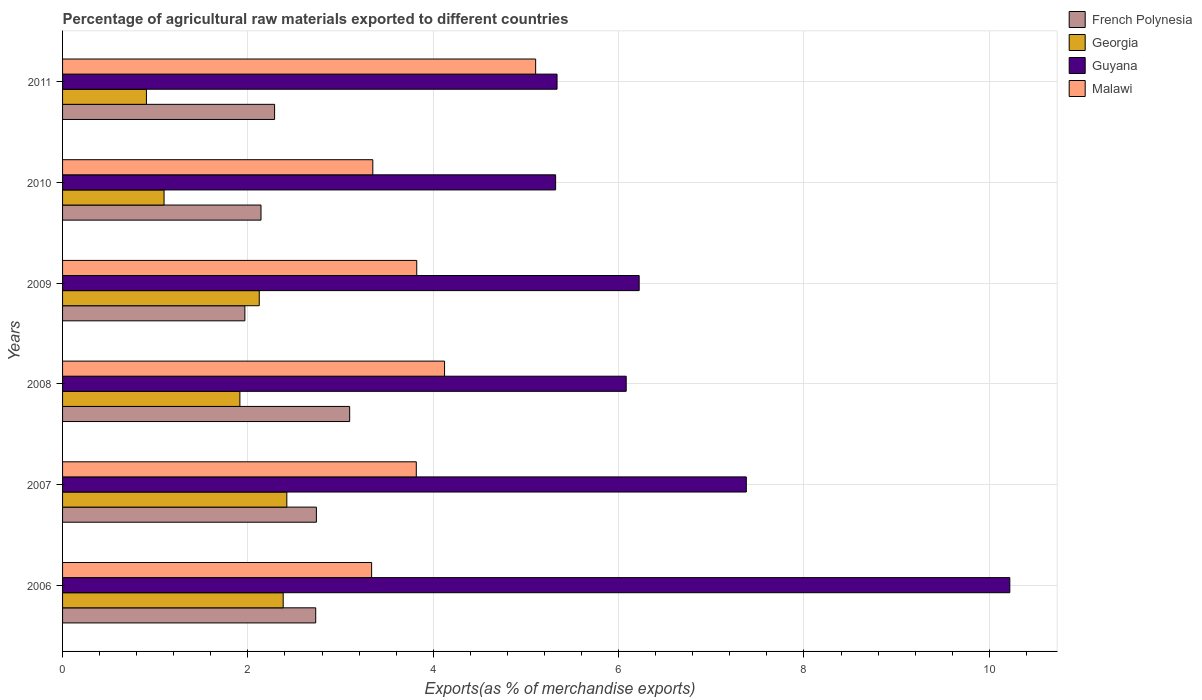How many different coloured bars are there?
Provide a short and direct response. 4. How many groups of bars are there?
Your response must be concise. 6. How many bars are there on the 4th tick from the top?
Offer a very short reply. 4. How many bars are there on the 3rd tick from the bottom?
Provide a succinct answer. 4. What is the label of the 1st group of bars from the top?
Your answer should be compact. 2011. What is the percentage of exports to different countries in Malawi in 2009?
Offer a very short reply. 3.82. Across all years, what is the maximum percentage of exports to different countries in French Polynesia?
Make the answer very short. 3.1. Across all years, what is the minimum percentage of exports to different countries in Georgia?
Your response must be concise. 0.91. In which year was the percentage of exports to different countries in Georgia minimum?
Your answer should be very brief. 2011. What is the total percentage of exports to different countries in Malawi in the graph?
Provide a short and direct response. 23.55. What is the difference between the percentage of exports to different countries in Guyana in 2006 and that in 2009?
Offer a terse response. 4. What is the difference between the percentage of exports to different countries in Georgia in 2006 and the percentage of exports to different countries in Guyana in 2008?
Your response must be concise. -3.7. What is the average percentage of exports to different countries in French Polynesia per year?
Your answer should be very brief. 2.49. In the year 2006, what is the difference between the percentage of exports to different countries in Georgia and percentage of exports to different countries in Malawi?
Provide a short and direct response. -0.95. What is the ratio of the percentage of exports to different countries in Georgia in 2008 to that in 2010?
Provide a succinct answer. 1.75. Is the percentage of exports to different countries in French Polynesia in 2010 less than that in 2011?
Your answer should be compact. Yes. Is the difference between the percentage of exports to different countries in Georgia in 2010 and 2011 greater than the difference between the percentage of exports to different countries in Malawi in 2010 and 2011?
Keep it short and to the point. Yes. What is the difference between the highest and the second highest percentage of exports to different countries in Georgia?
Provide a succinct answer. 0.04. What is the difference between the highest and the lowest percentage of exports to different countries in Georgia?
Keep it short and to the point. 1.51. In how many years, is the percentage of exports to different countries in Malawi greater than the average percentage of exports to different countries in Malawi taken over all years?
Make the answer very short. 2. What does the 3rd bar from the top in 2010 represents?
Your response must be concise. Georgia. What does the 2nd bar from the bottom in 2007 represents?
Give a very brief answer. Georgia. Is it the case that in every year, the sum of the percentage of exports to different countries in Georgia and percentage of exports to different countries in Malawi is greater than the percentage of exports to different countries in Guyana?
Your response must be concise. No. What is the difference between two consecutive major ticks on the X-axis?
Keep it short and to the point. 2. Does the graph contain grids?
Keep it short and to the point. Yes. How are the legend labels stacked?
Offer a very short reply. Vertical. What is the title of the graph?
Your answer should be very brief. Percentage of agricultural raw materials exported to different countries. What is the label or title of the X-axis?
Offer a terse response. Exports(as % of merchandise exports). What is the Exports(as % of merchandise exports) in French Polynesia in 2006?
Ensure brevity in your answer.  2.73. What is the Exports(as % of merchandise exports) in Georgia in 2006?
Offer a terse response. 2.38. What is the Exports(as % of merchandise exports) of Guyana in 2006?
Ensure brevity in your answer.  10.22. What is the Exports(as % of merchandise exports) of Malawi in 2006?
Provide a succinct answer. 3.33. What is the Exports(as % of merchandise exports) of French Polynesia in 2007?
Offer a terse response. 2.74. What is the Exports(as % of merchandise exports) in Georgia in 2007?
Give a very brief answer. 2.42. What is the Exports(as % of merchandise exports) of Guyana in 2007?
Your response must be concise. 7.38. What is the Exports(as % of merchandise exports) of Malawi in 2007?
Make the answer very short. 3.82. What is the Exports(as % of merchandise exports) of French Polynesia in 2008?
Your answer should be compact. 3.1. What is the Exports(as % of merchandise exports) of Georgia in 2008?
Provide a short and direct response. 1.91. What is the Exports(as % of merchandise exports) in Guyana in 2008?
Provide a short and direct response. 6.08. What is the Exports(as % of merchandise exports) of Malawi in 2008?
Provide a short and direct response. 4.12. What is the Exports(as % of merchandise exports) of French Polynesia in 2009?
Keep it short and to the point. 1.97. What is the Exports(as % of merchandise exports) in Georgia in 2009?
Provide a succinct answer. 2.12. What is the Exports(as % of merchandise exports) of Guyana in 2009?
Give a very brief answer. 6.22. What is the Exports(as % of merchandise exports) of Malawi in 2009?
Your response must be concise. 3.82. What is the Exports(as % of merchandise exports) in French Polynesia in 2010?
Make the answer very short. 2.14. What is the Exports(as % of merchandise exports) in Georgia in 2010?
Make the answer very short. 1.1. What is the Exports(as % of merchandise exports) of Guyana in 2010?
Your answer should be compact. 5.32. What is the Exports(as % of merchandise exports) of Malawi in 2010?
Your answer should be compact. 3.35. What is the Exports(as % of merchandise exports) of French Polynesia in 2011?
Provide a succinct answer. 2.29. What is the Exports(as % of merchandise exports) of Georgia in 2011?
Provide a short and direct response. 0.91. What is the Exports(as % of merchandise exports) in Guyana in 2011?
Keep it short and to the point. 5.34. What is the Exports(as % of merchandise exports) in Malawi in 2011?
Your answer should be very brief. 5.1. Across all years, what is the maximum Exports(as % of merchandise exports) of French Polynesia?
Your answer should be compact. 3.1. Across all years, what is the maximum Exports(as % of merchandise exports) in Georgia?
Keep it short and to the point. 2.42. Across all years, what is the maximum Exports(as % of merchandise exports) of Guyana?
Provide a succinct answer. 10.22. Across all years, what is the maximum Exports(as % of merchandise exports) in Malawi?
Offer a terse response. 5.1. Across all years, what is the minimum Exports(as % of merchandise exports) in French Polynesia?
Give a very brief answer. 1.97. Across all years, what is the minimum Exports(as % of merchandise exports) in Georgia?
Keep it short and to the point. 0.91. Across all years, what is the minimum Exports(as % of merchandise exports) of Guyana?
Your answer should be very brief. 5.32. Across all years, what is the minimum Exports(as % of merchandise exports) of Malawi?
Keep it short and to the point. 3.33. What is the total Exports(as % of merchandise exports) in French Polynesia in the graph?
Provide a succinct answer. 14.96. What is the total Exports(as % of merchandise exports) in Georgia in the graph?
Your answer should be very brief. 10.84. What is the total Exports(as % of merchandise exports) in Guyana in the graph?
Provide a succinct answer. 40.56. What is the total Exports(as % of merchandise exports) in Malawi in the graph?
Ensure brevity in your answer.  23.55. What is the difference between the Exports(as % of merchandise exports) of French Polynesia in 2006 and that in 2007?
Give a very brief answer. -0.01. What is the difference between the Exports(as % of merchandise exports) of Georgia in 2006 and that in 2007?
Offer a very short reply. -0.04. What is the difference between the Exports(as % of merchandise exports) of Guyana in 2006 and that in 2007?
Offer a very short reply. 2.84. What is the difference between the Exports(as % of merchandise exports) in Malawi in 2006 and that in 2007?
Provide a succinct answer. -0.48. What is the difference between the Exports(as % of merchandise exports) in French Polynesia in 2006 and that in 2008?
Keep it short and to the point. -0.37. What is the difference between the Exports(as % of merchandise exports) in Georgia in 2006 and that in 2008?
Make the answer very short. 0.47. What is the difference between the Exports(as % of merchandise exports) in Guyana in 2006 and that in 2008?
Provide a short and direct response. 4.14. What is the difference between the Exports(as % of merchandise exports) in Malawi in 2006 and that in 2008?
Ensure brevity in your answer.  -0.79. What is the difference between the Exports(as % of merchandise exports) of French Polynesia in 2006 and that in 2009?
Offer a terse response. 0.76. What is the difference between the Exports(as % of merchandise exports) in Georgia in 2006 and that in 2009?
Your answer should be compact. 0.26. What is the difference between the Exports(as % of merchandise exports) in Guyana in 2006 and that in 2009?
Ensure brevity in your answer.  4. What is the difference between the Exports(as % of merchandise exports) in Malawi in 2006 and that in 2009?
Provide a succinct answer. -0.49. What is the difference between the Exports(as % of merchandise exports) in French Polynesia in 2006 and that in 2010?
Offer a terse response. 0.59. What is the difference between the Exports(as % of merchandise exports) in Georgia in 2006 and that in 2010?
Provide a short and direct response. 1.29. What is the difference between the Exports(as % of merchandise exports) in Guyana in 2006 and that in 2010?
Your answer should be compact. 4.9. What is the difference between the Exports(as % of merchandise exports) of Malawi in 2006 and that in 2010?
Your answer should be compact. -0.01. What is the difference between the Exports(as % of merchandise exports) in French Polynesia in 2006 and that in 2011?
Provide a short and direct response. 0.44. What is the difference between the Exports(as % of merchandise exports) of Georgia in 2006 and that in 2011?
Ensure brevity in your answer.  1.48. What is the difference between the Exports(as % of merchandise exports) of Guyana in 2006 and that in 2011?
Ensure brevity in your answer.  4.89. What is the difference between the Exports(as % of merchandise exports) of Malawi in 2006 and that in 2011?
Your response must be concise. -1.77. What is the difference between the Exports(as % of merchandise exports) of French Polynesia in 2007 and that in 2008?
Offer a terse response. -0.36. What is the difference between the Exports(as % of merchandise exports) of Georgia in 2007 and that in 2008?
Make the answer very short. 0.51. What is the difference between the Exports(as % of merchandise exports) of Guyana in 2007 and that in 2008?
Ensure brevity in your answer.  1.3. What is the difference between the Exports(as % of merchandise exports) in Malawi in 2007 and that in 2008?
Your answer should be compact. -0.3. What is the difference between the Exports(as % of merchandise exports) in French Polynesia in 2007 and that in 2009?
Your response must be concise. 0.77. What is the difference between the Exports(as % of merchandise exports) of Georgia in 2007 and that in 2009?
Ensure brevity in your answer.  0.3. What is the difference between the Exports(as % of merchandise exports) in Guyana in 2007 and that in 2009?
Offer a terse response. 1.16. What is the difference between the Exports(as % of merchandise exports) in Malawi in 2007 and that in 2009?
Ensure brevity in your answer.  -0. What is the difference between the Exports(as % of merchandise exports) of French Polynesia in 2007 and that in 2010?
Provide a succinct answer. 0.6. What is the difference between the Exports(as % of merchandise exports) of Georgia in 2007 and that in 2010?
Offer a terse response. 1.32. What is the difference between the Exports(as % of merchandise exports) in Guyana in 2007 and that in 2010?
Offer a very short reply. 2.06. What is the difference between the Exports(as % of merchandise exports) in Malawi in 2007 and that in 2010?
Your answer should be compact. 0.47. What is the difference between the Exports(as % of merchandise exports) of French Polynesia in 2007 and that in 2011?
Keep it short and to the point. 0.45. What is the difference between the Exports(as % of merchandise exports) of Georgia in 2007 and that in 2011?
Ensure brevity in your answer.  1.51. What is the difference between the Exports(as % of merchandise exports) in Guyana in 2007 and that in 2011?
Your answer should be very brief. 2.04. What is the difference between the Exports(as % of merchandise exports) of Malawi in 2007 and that in 2011?
Make the answer very short. -1.29. What is the difference between the Exports(as % of merchandise exports) in French Polynesia in 2008 and that in 2009?
Your answer should be very brief. 1.13. What is the difference between the Exports(as % of merchandise exports) of Georgia in 2008 and that in 2009?
Give a very brief answer. -0.21. What is the difference between the Exports(as % of merchandise exports) of Guyana in 2008 and that in 2009?
Ensure brevity in your answer.  -0.14. What is the difference between the Exports(as % of merchandise exports) of Malawi in 2008 and that in 2009?
Provide a short and direct response. 0.3. What is the difference between the Exports(as % of merchandise exports) of French Polynesia in 2008 and that in 2010?
Make the answer very short. 0.96. What is the difference between the Exports(as % of merchandise exports) of Georgia in 2008 and that in 2010?
Keep it short and to the point. 0.82. What is the difference between the Exports(as % of merchandise exports) of Guyana in 2008 and that in 2010?
Provide a short and direct response. 0.76. What is the difference between the Exports(as % of merchandise exports) in Malawi in 2008 and that in 2010?
Keep it short and to the point. 0.77. What is the difference between the Exports(as % of merchandise exports) in French Polynesia in 2008 and that in 2011?
Offer a very short reply. 0.81. What is the difference between the Exports(as % of merchandise exports) of Georgia in 2008 and that in 2011?
Give a very brief answer. 1.01. What is the difference between the Exports(as % of merchandise exports) in Guyana in 2008 and that in 2011?
Ensure brevity in your answer.  0.75. What is the difference between the Exports(as % of merchandise exports) of Malawi in 2008 and that in 2011?
Offer a terse response. -0.98. What is the difference between the Exports(as % of merchandise exports) in French Polynesia in 2009 and that in 2010?
Keep it short and to the point. -0.17. What is the difference between the Exports(as % of merchandise exports) in Georgia in 2009 and that in 2010?
Offer a very short reply. 1.03. What is the difference between the Exports(as % of merchandise exports) in Guyana in 2009 and that in 2010?
Your response must be concise. 0.9. What is the difference between the Exports(as % of merchandise exports) in Malawi in 2009 and that in 2010?
Provide a succinct answer. 0.47. What is the difference between the Exports(as % of merchandise exports) of French Polynesia in 2009 and that in 2011?
Your response must be concise. -0.32. What is the difference between the Exports(as % of merchandise exports) of Georgia in 2009 and that in 2011?
Make the answer very short. 1.22. What is the difference between the Exports(as % of merchandise exports) of Guyana in 2009 and that in 2011?
Offer a terse response. 0.89. What is the difference between the Exports(as % of merchandise exports) in Malawi in 2009 and that in 2011?
Your answer should be very brief. -1.28. What is the difference between the Exports(as % of merchandise exports) of French Polynesia in 2010 and that in 2011?
Offer a very short reply. -0.15. What is the difference between the Exports(as % of merchandise exports) in Georgia in 2010 and that in 2011?
Offer a terse response. 0.19. What is the difference between the Exports(as % of merchandise exports) in Guyana in 2010 and that in 2011?
Ensure brevity in your answer.  -0.02. What is the difference between the Exports(as % of merchandise exports) of Malawi in 2010 and that in 2011?
Your answer should be compact. -1.76. What is the difference between the Exports(as % of merchandise exports) of French Polynesia in 2006 and the Exports(as % of merchandise exports) of Georgia in 2007?
Your response must be concise. 0.31. What is the difference between the Exports(as % of merchandise exports) of French Polynesia in 2006 and the Exports(as % of merchandise exports) of Guyana in 2007?
Give a very brief answer. -4.65. What is the difference between the Exports(as % of merchandise exports) of French Polynesia in 2006 and the Exports(as % of merchandise exports) of Malawi in 2007?
Provide a short and direct response. -1.09. What is the difference between the Exports(as % of merchandise exports) in Georgia in 2006 and the Exports(as % of merchandise exports) in Guyana in 2007?
Offer a terse response. -5. What is the difference between the Exports(as % of merchandise exports) in Georgia in 2006 and the Exports(as % of merchandise exports) in Malawi in 2007?
Your answer should be compact. -1.44. What is the difference between the Exports(as % of merchandise exports) of Guyana in 2006 and the Exports(as % of merchandise exports) of Malawi in 2007?
Your response must be concise. 6.4. What is the difference between the Exports(as % of merchandise exports) of French Polynesia in 2006 and the Exports(as % of merchandise exports) of Georgia in 2008?
Provide a short and direct response. 0.82. What is the difference between the Exports(as % of merchandise exports) of French Polynesia in 2006 and the Exports(as % of merchandise exports) of Guyana in 2008?
Keep it short and to the point. -3.35. What is the difference between the Exports(as % of merchandise exports) of French Polynesia in 2006 and the Exports(as % of merchandise exports) of Malawi in 2008?
Keep it short and to the point. -1.39. What is the difference between the Exports(as % of merchandise exports) in Georgia in 2006 and the Exports(as % of merchandise exports) in Guyana in 2008?
Offer a very short reply. -3.7. What is the difference between the Exports(as % of merchandise exports) in Georgia in 2006 and the Exports(as % of merchandise exports) in Malawi in 2008?
Provide a short and direct response. -1.74. What is the difference between the Exports(as % of merchandise exports) in Guyana in 2006 and the Exports(as % of merchandise exports) in Malawi in 2008?
Your answer should be very brief. 6.1. What is the difference between the Exports(as % of merchandise exports) in French Polynesia in 2006 and the Exports(as % of merchandise exports) in Georgia in 2009?
Your answer should be compact. 0.61. What is the difference between the Exports(as % of merchandise exports) of French Polynesia in 2006 and the Exports(as % of merchandise exports) of Guyana in 2009?
Your response must be concise. -3.49. What is the difference between the Exports(as % of merchandise exports) of French Polynesia in 2006 and the Exports(as % of merchandise exports) of Malawi in 2009?
Your answer should be compact. -1.09. What is the difference between the Exports(as % of merchandise exports) of Georgia in 2006 and the Exports(as % of merchandise exports) of Guyana in 2009?
Offer a terse response. -3.84. What is the difference between the Exports(as % of merchandise exports) in Georgia in 2006 and the Exports(as % of merchandise exports) in Malawi in 2009?
Make the answer very short. -1.44. What is the difference between the Exports(as % of merchandise exports) of Guyana in 2006 and the Exports(as % of merchandise exports) of Malawi in 2009?
Give a very brief answer. 6.4. What is the difference between the Exports(as % of merchandise exports) in French Polynesia in 2006 and the Exports(as % of merchandise exports) in Georgia in 2010?
Keep it short and to the point. 1.64. What is the difference between the Exports(as % of merchandise exports) in French Polynesia in 2006 and the Exports(as % of merchandise exports) in Guyana in 2010?
Provide a short and direct response. -2.59. What is the difference between the Exports(as % of merchandise exports) in French Polynesia in 2006 and the Exports(as % of merchandise exports) in Malawi in 2010?
Your response must be concise. -0.62. What is the difference between the Exports(as % of merchandise exports) of Georgia in 2006 and the Exports(as % of merchandise exports) of Guyana in 2010?
Provide a succinct answer. -2.94. What is the difference between the Exports(as % of merchandise exports) in Georgia in 2006 and the Exports(as % of merchandise exports) in Malawi in 2010?
Your answer should be compact. -0.97. What is the difference between the Exports(as % of merchandise exports) in Guyana in 2006 and the Exports(as % of merchandise exports) in Malawi in 2010?
Offer a terse response. 6.87. What is the difference between the Exports(as % of merchandise exports) in French Polynesia in 2006 and the Exports(as % of merchandise exports) in Georgia in 2011?
Your answer should be compact. 1.83. What is the difference between the Exports(as % of merchandise exports) of French Polynesia in 2006 and the Exports(as % of merchandise exports) of Guyana in 2011?
Your answer should be very brief. -2.6. What is the difference between the Exports(as % of merchandise exports) of French Polynesia in 2006 and the Exports(as % of merchandise exports) of Malawi in 2011?
Make the answer very short. -2.37. What is the difference between the Exports(as % of merchandise exports) of Georgia in 2006 and the Exports(as % of merchandise exports) of Guyana in 2011?
Give a very brief answer. -2.96. What is the difference between the Exports(as % of merchandise exports) of Georgia in 2006 and the Exports(as % of merchandise exports) of Malawi in 2011?
Give a very brief answer. -2.72. What is the difference between the Exports(as % of merchandise exports) of Guyana in 2006 and the Exports(as % of merchandise exports) of Malawi in 2011?
Your response must be concise. 5.12. What is the difference between the Exports(as % of merchandise exports) of French Polynesia in 2007 and the Exports(as % of merchandise exports) of Georgia in 2008?
Your answer should be very brief. 0.83. What is the difference between the Exports(as % of merchandise exports) in French Polynesia in 2007 and the Exports(as % of merchandise exports) in Guyana in 2008?
Your response must be concise. -3.34. What is the difference between the Exports(as % of merchandise exports) in French Polynesia in 2007 and the Exports(as % of merchandise exports) in Malawi in 2008?
Offer a terse response. -1.38. What is the difference between the Exports(as % of merchandise exports) in Georgia in 2007 and the Exports(as % of merchandise exports) in Guyana in 2008?
Provide a succinct answer. -3.66. What is the difference between the Exports(as % of merchandise exports) of Georgia in 2007 and the Exports(as % of merchandise exports) of Malawi in 2008?
Your answer should be very brief. -1.7. What is the difference between the Exports(as % of merchandise exports) of Guyana in 2007 and the Exports(as % of merchandise exports) of Malawi in 2008?
Offer a terse response. 3.26. What is the difference between the Exports(as % of merchandise exports) of French Polynesia in 2007 and the Exports(as % of merchandise exports) of Georgia in 2009?
Make the answer very short. 0.62. What is the difference between the Exports(as % of merchandise exports) of French Polynesia in 2007 and the Exports(as % of merchandise exports) of Guyana in 2009?
Keep it short and to the point. -3.48. What is the difference between the Exports(as % of merchandise exports) in French Polynesia in 2007 and the Exports(as % of merchandise exports) in Malawi in 2009?
Make the answer very short. -1.08. What is the difference between the Exports(as % of merchandise exports) in Georgia in 2007 and the Exports(as % of merchandise exports) in Guyana in 2009?
Make the answer very short. -3.8. What is the difference between the Exports(as % of merchandise exports) of Georgia in 2007 and the Exports(as % of merchandise exports) of Malawi in 2009?
Make the answer very short. -1.4. What is the difference between the Exports(as % of merchandise exports) in Guyana in 2007 and the Exports(as % of merchandise exports) in Malawi in 2009?
Provide a succinct answer. 3.56. What is the difference between the Exports(as % of merchandise exports) of French Polynesia in 2007 and the Exports(as % of merchandise exports) of Georgia in 2010?
Make the answer very short. 1.64. What is the difference between the Exports(as % of merchandise exports) in French Polynesia in 2007 and the Exports(as % of merchandise exports) in Guyana in 2010?
Your answer should be very brief. -2.58. What is the difference between the Exports(as % of merchandise exports) in French Polynesia in 2007 and the Exports(as % of merchandise exports) in Malawi in 2010?
Make the answer very short. -0.61. What is the difference between the Exports(as % of merchandise exports) of Georgia in 2007 and the Exports(as % of merchandise exports) of Guyana in 2010?
Provide a succinct answer. -2.9. What is the difference between the Exports(as % of merchandise exports) of Georgia in 2007 and the Exports(as % of merchandise exports) of Malawi in 2010?
Your response must be concise. -0.93. What is the difference between the Exports(as % of merchandise exports) of Guyana in 2007 and the Exports(as % of merchandise exports) of Malawi in 2010?
Your response must be concise. 4.03. What is the difference between the Exports(as % of merchandise exports) of French Polynesia in 2007 and the Exports(as % of merchandise exports) of Georgia in 2011?
Offer a terse response. 1.83. What is the difference between the Exports(as % of merchandise exports) of French Polynesia in 2007 and the Exports(as % of merchandise exports) of Guyana in 2011?
Give a very brief answer. -2.6. What is the difference between the Exports(as % of merchandise exports) in French Polynesia in 2007 and the Exports(as % of merchandise exports) in Malawi in 2011?
Offer a terse response. -2.37. What is the difference between the Exports(as % of merchandise exports) of Georgia in 2007 and the Exports(as % of merchandise exports) of Guyana in 2011?
Your answer should be compact. -2.92. What is the difference between the Exports(as % of merchandise exports) in Georgia in 2007 and the Exports(as % of merchandise exports) in Malawi in 2011?
Provide a short and direct response. -2.69. What is the difference between the Exports(as % of merchandise exports) in Guyana in 2007 and the Exports(as % of merchandise exports) in Malawi in 2011?
Your answer should be compact. 2.27. What is the difference between the Exports(as % of merchandise exports) in French Polynesia in 2008 and the Exports(as % of merchandise exports) in Georgia in 2009?
Give a very brief answer. 0.98. What is the difference between the Exports(as % of merchandise exports) in French Polynesia in 2008 and the Exports(as % of merchandise exports) in Guyana in 2009?
Provide a short and direct response. -3.12. What is the difference between the Exports(as % of merchandise exports) in French Polynesia in 2008 and the Exports(as % of merchandise exports) in Malawi in 2009?
Provide a succinct answer. -0.72. What is the difference between the Exports(as % of merchandise exports) of Georgia in 2008 and the Exports(as % of merchandise exports) of Guyana in 2009?
Offer a very short reply. -4.31. What is the difference between the Exports(as % of merchandise exports) of Georgia in 2008 and the Exports(as % of merchandise exports) of Malawi in 2009?
Your answer should be very brief. -1.91. What is the difference between the Exports(as % of merchandise exports) in Guyana in 2008 and the Exports(as % of merchandise exports) in Malawi in 2009?
Keep it short and to the point. 2.26. What is the difference between the Exports(as % of merchandise exports) of French Polynesia in 2008 and the Exports(as % of merchandise exports) of Georgia in 2010?
Give a very brief answer. 2. What is the difference between the Exports(as % of merchandise exports) in French Polynesia in 2008 and the Exports(as % of merchandise exports) in Guyana in 2010?
Your answer should be very brief. -2.22. What is the difference between the Exports(as % of merchandise exports) in French Polynesia in 2008 and the Exports(as % of merchandise exports) in Malawi in 2010?
Offer a terse response. -0.25. What is the difference between the Exports(as % of merchandise exports) in Georgia in 2008 and the Exports(as % of merchandise exports) in Guyana in 2010?
Make the answer very short. -3.41. What is the difference between the Exports(as % of merchandise exports) in Georgia in 2008 and the Exports(as % of merchandise exports) in Malawi in 2010?
Provide a succinct answer. -1.43. What is the difference between the Exports(as % of merchandise exports) of Guyana in 2008 and the Exports(as % of merchandise exports) of Malawi in 2010?
Your answer should be very brief. 2.73. What is the difference between the Exports(as % of merchandise exports) of French Polynesia in 2008 and the Exports(as % of merchandise exports) of Georgia in 2011?
Ensure brevity in your answer.  2.19. What is the difference between the Exports(as % of merchandise exports) in French Polynesia in 2008 and the Exports(as % of merchandise exports) in Guyana in 2011?
Your answer should be very brief. -2.24. What is the difference between the Exports(as % of merchandise exports) of French Polynesia in 2008 and the Exports(as % of merchandise exports) of Malawi in 2011?
Keep it short and to the point. -2.01. What is the difference between the Exports(as % of merchandise exports) of Georgia in 2008 and the Exports(as % of merchandise exports) of Guyana in 2011?
Your answer should be very brief. -3.42. What is the difference between the Exports(as % of merchandise exports) of Georgia in 2008 and the Exports(as % of merchandise exports) of Malawi in 2011?
Your answer should be very brief. -3.19. What is the difference between the Exports(as % of merchandise exports) in Guyana in 2008 and the Exports(as % of merchandise exports) in Malawi in 2011?
Your answer should be compact. 0.98. What is the difference between the Exports(as % of merchandise exports) of French Polynesia in 2009 and the Exports(as % of merchandise exports) of Georgia in 2010?
Provide a short and direct response. 0.87. What is the difference between the Exports(as % of merchandise exports) in French Polynesia in 2009 and the Exports(as % of merchandise exports) in Guyana in 2010?
Your answer should be compact. -3.35. What is the difference between the Exports(as % of merchandise exports) in French Polynesia in 2009 and the Exports(as % of merchandise exports) in Malawi in 2010?
Keep it short and to the point. -1.38. What is the difference between the Exports(as % of merchandise exports) in Georgia in 2009 and the Exports(as % of merchandise exports) in Guyana in 2010?
Keep it short and to the point. -3.2. What is the difference between the Exports(as % of merchandise exports) in Georgia in 2009 and the Exports(as % of merchandise exports) in Malawi in 2010?
Your response must be concise. -1.23. What is the difference between the Exports(as % of merchandise exports) in Guyana in 2009 and the Exports(as % of merchandise exports) in Malawi in 2010?
Offer a terse response. 2.87. What is the difference between the Exports(as % of merchandise exports) of French Polynesia in 2009 and the Exports(as % of merchandise exports) of Georgia in 2011?
Ensure brevity in your answer.  1.06. What is the difference between the Exports(as % of merchandise exports) of French Polynesia in 2009 and the Exports(as % of merchandise exports) of Guyana in 2011?
Offer a very short reply. -3.37. What is the difference between the Exports(as % of merchandise exports) in French Polynesia in 2009 and the Exports(as % of merchandise exports) in Malawi in 2011?
Your answer should be compact. -3.14. What is the difference between the Exports(as % of merchandise exports) of Georgia in 2009 and the Exports(as % of merchandise exports) of Guyana in 2011?
Make the answer very short. -3.21. What is the difference between the Exports(as % of merchandise exports) in Georgia in 2009 and the Exports(as % of merchandise exports) in Malawi in 2011?
Provide a succinct answer. -2.98. What is the difference between the Exports(as % of merchandise exports) in Guyana in 2009 and the Exports(as % of merchandise exports) in Malawi in 2011?
Give a very brief answer. 1.12. What is the difference between the Exports(as % of merchandise exports) in French Polynesia in 2010 and the Exports(as % of merchandise exports) in Georgia in 2011?
Ensure brevity in your answer.  1.24. What is the difference between the Exports(as % of merchandise exports) of French Polynesia in 2010 and the Exports(as % of merchandise exports) of Guyana in 2011?
Make the answer very short. -3.19. What is the difference between the Exports(as % of merchandise exports) in French Polynesia in 2010 and the Exports(as % of merchandise exports) in Malawi in 2011?
Offer a terse response. -2.96. What is the difference between the Exports(as % of merchandise exports) of Georgia in 2010 and the Exports(as % of merchandise exports) of Guyana in 2011?
Keep it short and to the point. -4.24. What is the difference between the Exports(as % of merchandise exports) of Georgia in 2010 and the Exports(as % of merchandise exports) of Malawi in 2011?
Keep it short and to the point. -4.01. What is the difference between the Exports(as % of merchandise exports) of Guyana in 2010 and the Exports(as % of merchandise exports) of Malawi in 2011?
Your response must be concise. 0.22. What is the average Exports(as % of merchandise exports) of French Polynesia per year?
Make the answer very short. 2.49. What is the average Exports(as % of merchandise exports) in Georgia per year?
Offer a very short reply. 1.81. What is the average Exports(as % of merchandise exports) in Guyana per year?
Your response must be concise. 6.76. What is the average Exports(as % of merchandise exports) of Malawi per year?
Provide a short and direct response. 3.92. In the year 2006, what is the difference between the Exports(as % of merchandise exports) of French Polynesia and Exports(as % of merchandise exports) of Georgia?
Give a very brief answer. 0.35. In the year 2006, what is the difference between the Exports(as % of merchandise exports) in French Polynesia and Exports(as % of merchandise exports) in Guyana?
Give a very brief answer. -7.49. In the year 2006, what is the difference between the Exports(as % of merchandise exports) of French Polynesia and Exports(as % of merchandise exports) of Malawi?
Your answer should be compact. -0.6. In the year 2006, what is the difference between the Exports(as % of merchandise exports) of Georgia and Exports(as % of merchandise exports) of Guyana?
Make the answer very short. -7.84. In the year 2006, what is the difference between the Exports(as % of merchandise exports) in Georgia and Exports(as % of merchandise exports) in Malawi?
Provide a succinct answer. -0.95. In the year 2006, what is the difference between the Exports(as % of merchandise exports) of Guyana and Exports(as % of merchandise exports) of Malawi?
Ensure brevity in your answer.  6.89. In the year 2007, what is the difference between the Exports(as % of merchandise exports) of French Polynesia and Exports(as % of merchandise exports) of Georgia?
Offer a terse response. 0.32. In the year 2007, what is the difference between the Exports(as % of merchandise exports) in French Polynesia and Exports(as % of merchandise exports) in Guyana?
Provide a short and direct response. -4.64. In the year 2007, what is the difference between the Exports(as % of merchandise exports) of French Polynesia and Exports(as % of merchandise exports) of Malawi?
Your answer should be compact. -1.08. In the year 2007, what is the difference between the Exports(as % of merchandise exports) of Georgia and Exports(as % of merchandise exports) of Guyana?
Keep it short and to the point. -4.96. In the year 2007, what is the difference between the Exports(as % of merchandise exports) of Georgia and Exports(as % of merchandise exports) of Malawi?
Give a very brief answer. -1.4. In the year 2007, what is the difference between the Exports(as % of merchandise exports) in Guyana and Exports(as % of merchandise exports) in Malawi?
Make the answer very short. 3.56. In the year 2008, what is the difference between the Exports(as % of merchandise exports) of French Polynesia and Exports(as % of merchandise exports) of Georgia?
Offer a very short reply. 1.18. In the year 2008, what is the difference between the Exports(as % of merchandise exports) of French Polynesia and Exports(as % of merchandise exports) of Guyana?
Offer a terse response. -2.98. In the year 2008, what is the difference between the Exports(as % of merchandise exports) of French Polynesia and Exports(as % of merchandise exports) of Malawi?
Ensure brevity in your answer.  -1.02. In the year 2008, what is the difference between the Exports(as % of merchandise exports) of Georgia and Exports(as % of merchandise exports) of Guyana?
Your response must be concise. -4.17. In the year 2008, what is the difference between the Exports(as % of merchandise exports) in Georgia and Exports(as % of merchandise exports) in Malawi?
Keep it short and to the point. -2.21. In the year 2008, what is the difference between the Exports(as % of merchandise exports) in Guyana and Exports(as % of merchandise exports) in Malawi?
Offer a very short reply. 1.96. In the year 2009, what is the difference between the Exports(as % of merchandise exports) in French Polynesia and Exports(as % of merchandise exports) in Georgia?
Offer a very short reply. -0.16. In the year 2009, what is the difference between the Exports(as % of merchandise exports) in French Polynesia and Exports(as % of merchandise exports) in Guyana?
Your answer should be compact. -4.25. In the year 2009, what is the difference between the Exports(as % of merchandise exports) of French Polynesia and Exports(as % of merchandise exports) of Malawi?
Ensure brevity in your answer.  -1.85. In the year 2009, what is the difference between the Exports(as % of merchandise exports) in Georgia and Exports(as % of merchandise exports) in Guyana?
Offer a terse response. -4.1. In the year 2009, what is the difference between the Exports(as % of merchandise exports) in Georgia and Exports(as % of merchandise exports) in Malawi?
Keep it short and to the point. -1.7. In the year 2009, what is the difference between the Exports(as % of merchandise exports) of Guyana and Exports(as % of merchandise exports) of Malawi?
Your answer should be compact. 2.4. In the year 2010, what is the difference between the Exports(as % of merchandise exports) in French Polynesia and Exports(as % of merchandise exports) in Georgia?
Your response must be concise. 1.05. In the year 2010, what is the difference between the Exports(as % of merchandise exports) in French Polynesia and Exports(as % of merchandise exports) in Guyana?
Keep it short and to the point. -3.18. In the year 2010, what is the difference between the Exports(as % of merchandise exports) of French Polynesia and Exports(as % of merchandise exports) of Malawi?
Give a very brief answer. -1.21. In the year 2010, what is the difference between the Exports(as % of merchandise exports) of Georgia and Exports(as % of merchandise exports) of Guyana?
Your response must be concise. -4.23. In the year 2010, what is the difference between the Exports(as % of merchandise exports) in Georgia and Exports(as % of merchandise exports) in Malawi?
Your answer should be very brief. -2.25. In the year 2010, what is the difference between the Exports(as % of merchandise exports) of Guyana and Exports(as % of merchandise exports) of Malawi?
Your answer should be compact. 1.97. In the year 2011, what is the difference between the Exports(as % of merchandise exports) in French Polynesia and Exports(as % of merchandise exports) in Georgia?
Offer a terse response. 1.38. In the year 2011, what is the difference between the Exports(as % of merchandise exports) of French Polynesia and Exports(as % of merchandise exports) of Guyana?
Ensure brevity in your answer.  -3.05. In the year 2011, what is the difference between the Exports(as % of merchandise exports) of French Polynesia and Exports(as % of merchandise exports) of Malawi?
Provide a succinct answer. -2.82. In the year 2011, what is the difference between the Exports(as % of merchandise exports) in Georgia and Exports(as % of merchandise exports) in Guyana?
Keep it short and to the point. -4.43. In the year 2011, what is the difference between the Exports(as % of merchandise exports) of Georgia and Exports(as % of merchandise exports) of Malawi?
Make the answer very short. -4.2. In the year 2011, what is the difference between the Exports(as % of merchandise exports) of Guyana and Exports(as % of merchandise exports) of Malawi?
Offer a very short reply. 0.23. What is the ratio of the Exports(as % of merchandise exports) of French Polynesia in 2006 to that in 2007?
Give a very brief answer. 1. What is the ratio of the Exports(as % of merchandise exports) of Georgia in 2006 to that in 2007?
Provide a succinct answer. 0.98. What is the ratio of the Exports(as % of merchandise exports) of Guyana in 2006 to that in 2007?
Offer a terse response. 1.39. What is the ratio of the Exports(as % of merchandise exports) in Malawi in 2006 to that in 2007?
Offer a very short reply. 0.87. What is the ratio of the Exports(as % of merchandise exports) in French Polynesia in 2006 to that in 2008?
Your answer should be very brief. 0.88. What is the ratio of the Exports(as % of merchandise exports) of Georgia in 2006 to that in 2008?
Provide a short and direct response. 1.24. What is the ratio of the Exports(as % of merchandise exports) in Guyana in 2006 to that in 2008?
Provide a succinct answer. 1.68. What is the ratio of the Exports(as % of merchandise exports) in Malawi in 2006 to that in 2008?
Your answer should be very brief. 0.81. What is the ratio of the Exports(as % of merchandise exports) of French Polynesia in 2006 to that in 2009?
Make the answer very short. 1.39. What is the ratio of the Exports(as % of merchandise exports) in Georgia in 2006 to that in 2009?
Your answer should be very brief. 1.12. What is the ratio of the Exports(as % of merchandise exports) in Guyana in 2006 to that in 2009?
Your answer should be compact. 1.64. What is the ratio of the Exports(as % of merchandise exports) of Malawi in 2006 to that in 2009?
Provide a short and direct response. 0.87. What is the ratio of the Exports(as % of merchandise exports) of French Polynesia in 2006 to that in 2010?
Offer a very short reply. 1.28. What is the ratio of the Exports(as % of merchandise exports) of Georgia in 2006 to that in 2010?
Provide a succinct answer. 2.17. What is the ratio of the Exports(as % of merchandise exports) of Guyana in 2006 to that in 2010?
Your answer should be compact. 1.92. What is the ratio of the Exports(as % of merchandise exports) of French Polynesia in 2006 to that in 2011?
Your response must be concise. 1.19. What is the ratio of the Exports(as % of merchandise exports) in Georgia in 2006 to that in 2011?
Keep it short and to the point. 2.63. What is the ratio of the Exports(as % of merchandise exports) of Guyana in 2006 to that in 2011?
Offer a terse response. 1.92. What is the ratio of the Exports(as % of merchandise exports) in Malawi in 2006 to that in 2011?
Your response must be concise. 0.65. What is the ratio of the Exports(as % of merchandise exports) in French Polynesia in 2007 to that in 2008?
Offer a terse response. 0.88. What is the ratio of the Exports(as % of merchandise exports) of Georgia in 2007 to that in 2008?
Your response must be concise. 1.26. What is the ratio of the Exports(as % of merchandise exports) in Guyana in 2007 to that in 2008?
Provide a succinct answer. 1.21. What is the ratio of the Exports(as % of merchandise exports) in Malawi in 2007 to that in 2008?
Offer a terse response. 0.93. What is the ratio of the Exports(as % of merchandise exports) in French Polynesia in 2007 to that in 2009?
Provide a succinct answer. 1.39. What is the ratio of the Exports(as % of merchandise exports) of Georgia in 2007 to that in 2009?
Ensure brevity in your answer.  1.14. What is the ratio of the Exports(as % of merchandise exports) in Guyana in 2007 to that in 2009?
Give a very brief answer. 1.19. What is the ratio of the Exports(as % of merchandise exports) of Malawi in 2007 to that in 2009?
Offer a terse response. 1. What is the ratio of the Exports(as % of merchandise exports) of French Polynesia in 2007 to that in 2010?
Make the answer very short. 1.28. What is the ratio of the Exports(as % of merchandise exports) of Georgia in 2007 to that in 2010?
Offer a very short reply. 2.21. What is the ratio of the Exports(as % of merchandise exports) of Guyana in 2007 to that in 2010?
Offer a very short reply. 1.39. What is the ratio of the Exports(as % of merchandise exports) in Malawi in 2007 to that in 2010?
Your answer should be very brief. 1.14. What is the ratio of the Exports(as % of merchandise exports) of French Polynesia in 2007 to that in 2011?
Your answer should be very brief. 1.2. What is the ratio of the Exports(as % of merchandise exports) in Georgia in 2007 to that in 2011?
Provide a short and direct response. 2.67. What is the ratio of the Exports(as % of merchandise exports) of Guyana in 2007 to that in 2011?
Provide a short and direct response. 1.38. What is the ratio of the Exports(as % of merchandise exports) of Malawi in 2007 to that in 2011?
Give a very brief answer. 0.75. What is the ratio of the Exports(as % of merchandise exports) in French Polynesia in 2008 to that in 2009?
Provide a succinct answer. 1.57. What is the ratio of the Exports(as % of merchandise exports) in Georgia in 2008 to that in 2009?
Ensure brevity in your answer.  0.9. What is the ratio of the Exports(as % of merchandise exports) in Guyana in 2008 to that in 2009?
Your response must be concise. 0.98. What is the ratio of the Exports(as % of merchandise exports) of Malawi in 2008 to that in 2009?
Ensure brevity in your answer.  1.08. What is the ratio of the Exports(as % of merchandise exports) in French Polynesia in 2008 to that in 2010?
Your answer should be compact. 1.45. What is the ratio of the Exports(as % of merchandise exports) of Georgia in 2008 to that in 2010?
Your answer should be very brief. 1.75. What is the ratio of the Exports(as % of merchandise exports) of Guyana in 2008 to that in 2010?
Ensure brevity in your answer.  1.14. What is the ratio of the Exports(as % of merchandise exports) of Malawi in 2008 to that in 2010?
Give a very brief answer. 1.23. What is the ratio of the Exports(as % of merchandise exports) in French Polynesia in 2008 to that in 2011?
Ensure brevity in your answer.  1.35. What is the ratio of the Exports(as % of merchandise exports) of Georgia in 2008 to that in 2011?
Your answer should be compact. 2.11. What is the ratio of the Exports(as % of merchandise exports) of Guyana in 2008 to that in 2011?
Your answer should be compact. 1.14. What is the ratio of the Exports(as % of merchandise exports) of Malawi in 2008 to that in 2011?
Offer a terse response. 0.81. What is the ratio of the Exports(as % of merchandise exports) of French Polynesia in 2009 to that in 2010?
Your response must be concise. 0.92. What is the ratio of the Exports(as % of merchandise exports) of Georgia in 2009 to that in 2010?
Make the answer very short. 1.94. What is the ratio of the Exports(as % of merchandise exports) in Guyana in 2009 to that in 2010?
Offer a terse response. 1.17. What is the ratio of the Exports(as % of merchandise exports) of Malawi in 2009 to that in 2010?
Your answer should be compact. 1.14. What is the ratio of the Exports(as % of merchandise exports) in French Polynesia in 2009 to that in 2011?
Give a very brief answer. 0.86. What is the ratio of the Exports(as % of merchandise exports) in Georgia in 2009 to that in 2011?
Your response must be concise. 2.35. What is the ratio of the Exports(as % of merchandise exports) in Guyana in 2009 to that in 2011?
Make the answer very short. 1.17. What is the ratio of the Exports(as % of merchandise exports) in Malawi in 2009 to that in 2011?
Make the answer very short. 0.75. What is the ratio of the Exports(as % of merchandise exports) in French Polynesia in 2010 to that in 2011?
Keep it short and to the point. 0.94. What is the ratio of the Exports(as % of merchandise exports) in Georgia in 2010 to that in 2011?
Your answer should be compact. 1.21. What is the ratio of the Exports(as % of merchandise exports) in Guyana in 2010 to that in 2011?
Provide a succinct answer. 1. What is the ratio of the Exports(as % of merchandise exports) of Malawi in 2010 to that in 2011?
Offer a very short reply. 0.66. What is the difference between the highest and the second highest Exports(as % of merchandise exports) in French Polynesia?
Your response must be concise. 0.36. What is the difference between the highest and the second highest Exports(as % of merchandise exports) of Georgia?
Offer a terse response. 0.04. What is the difference between the highest and the second highest Exports(as % of merchandise exports) in Guyana?
Ensure brevity in your answer.  2.84. What is the difference between the highest and the second highest Exports(as % of merchandise exports) in Malawi?
Ensure brevity in your answer.  0.98. What is the difference between the highest and the lowest Exports(as % of merchandise exports) of French Polynesia?
Offer a very short reply. 1.13. What is the difference between the highest and the lowest Exports(as % of merchandise exports) of Georgia?
Ensure brevity in your answer.  1.51. What is the difference between the highest and the lowest Exports(as % of merchandise exports) of Guyana?
Offer a very short reply. 4.9. What is the difference between the highest and the lowest Exports(as % of merchandise exports) in Malawi?
Offer a terse response. 1.77. 